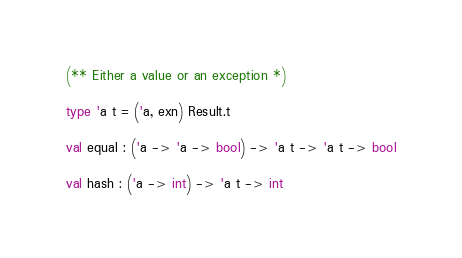<code> <loc_0><loc_0><loc_500><loc_500><_OCaml_>(** Either a value or an exception *)

type 'a t = ('a, exn) Result.t

val equal : ('a -> 'a -> bool) -> 'a t -> 'a t -> bool

val hash : ('a -> int) -> 'a t -> int
</code> 